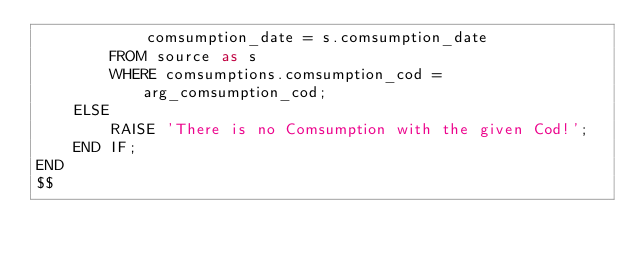Convert code to text. <code><loc_0><loc_0><loc_500><loc_500><_SQL_>            comsumption_date = s.comsumption_date
        FROM source as s
        WHERE comsumptions.comsumption_cod = arg_comsumption_cod;
    ELSE
        RAISE 'There is no Comsumption with the given Cod!';
    END IF;
END
$$</code> 